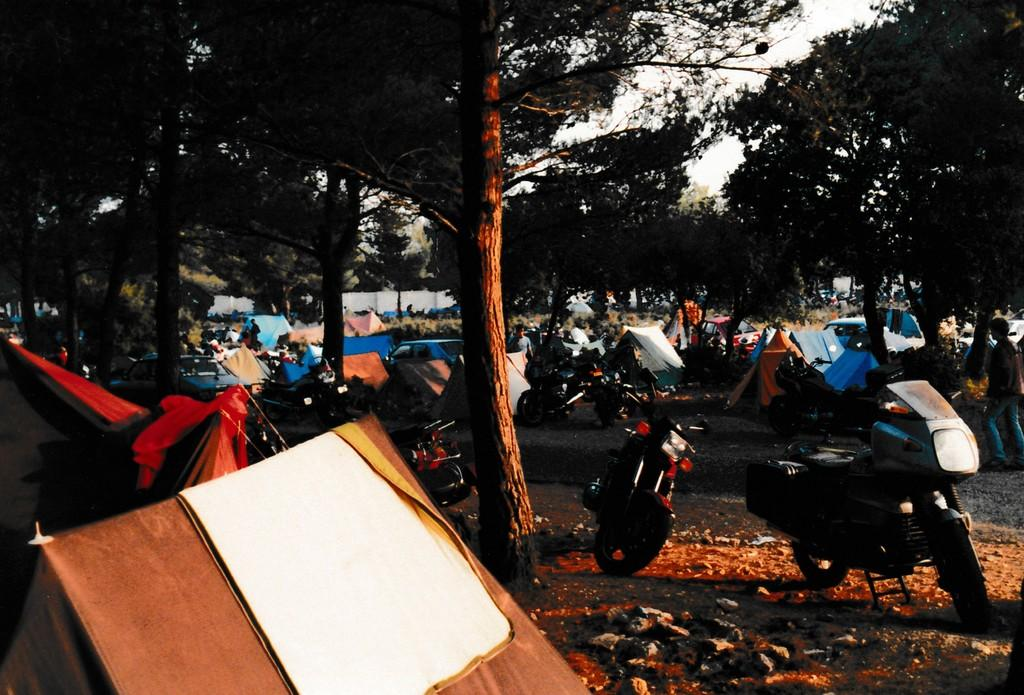What types of objects can be seen in the image? There are vehicles, stones, tents, and people visible in the image. What can be seen on the ground in the image? There are stones and a path visible in the image. What type of shelter is present in the image? There are tents in the image. Where are the people located in the image? The people are visible on the path in the image. What is visible in the background of the image? There are trees in the background of the image. What type of grain is being processed by the apparatus in the image? There is no apparatus or grain present in the image. What type of cover is being used to protect the tents in the image? There is no cover visible in the image; the tents are exposed. 